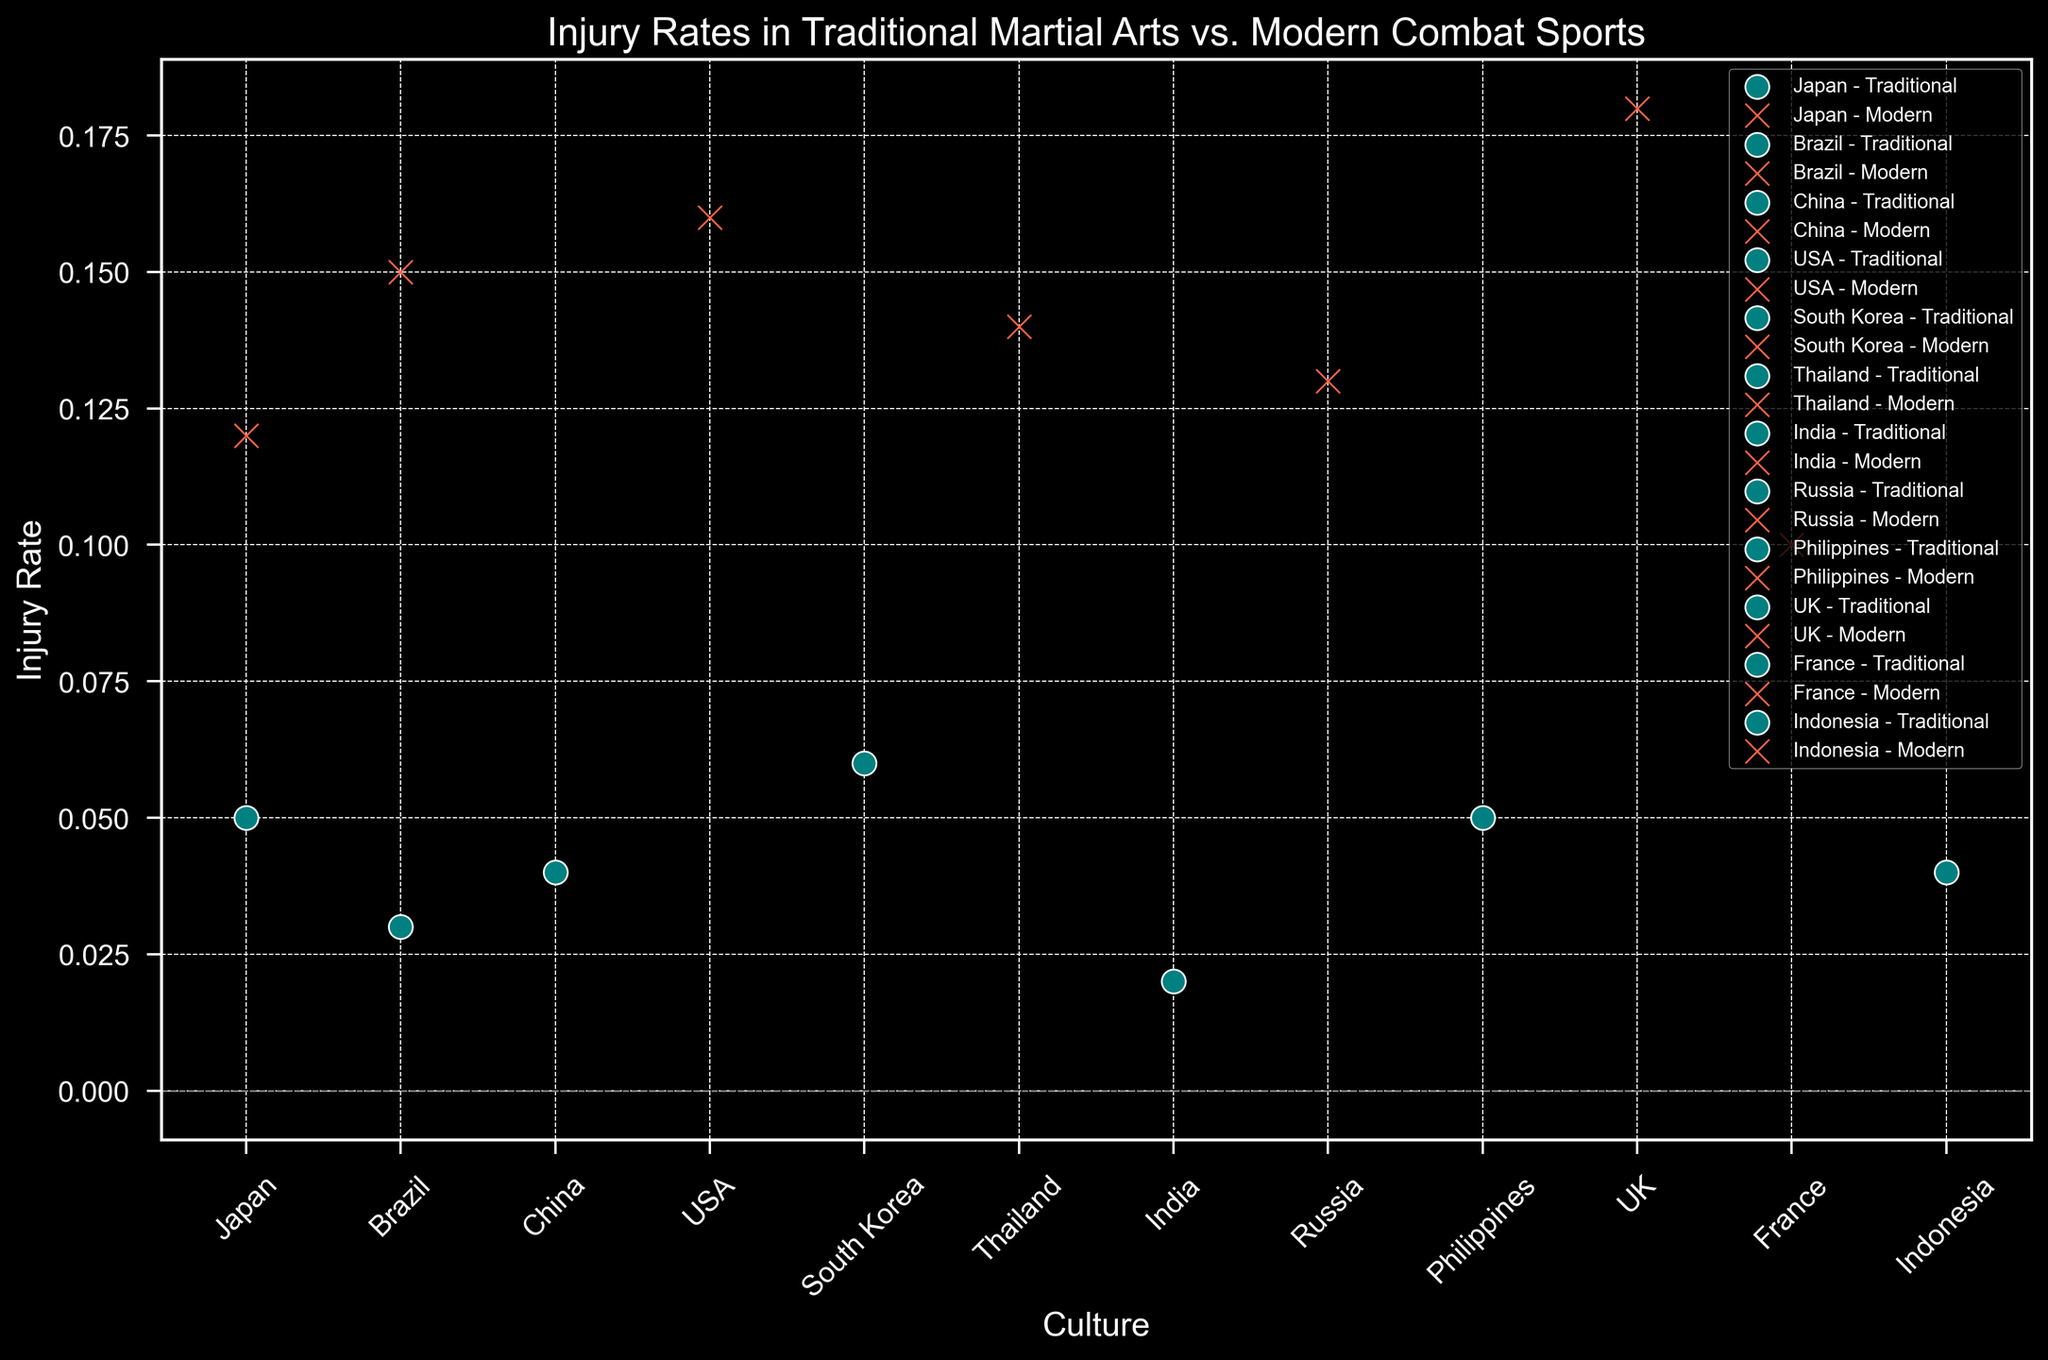How does the injury rate of Karate compare to Kickboxing in Japan? The injury rate of Karate in Japan is 0.05, and for Kickboxing, it is 0.12. By comparing these two rates, it's clear that the injury rate for Kickboxing is higher than for Karate.
Answer: Kickboxing has a higher injury rate What is the average injury rate of traditional martial arts from the given cultures? The traditional martial arts and their injury rates are Karate (0.05), Capoeira (0.03), Kung Fu (0.04), Taekwondo (0.06), Kalaripayattu (0.02), Eskrima (0.05), and Pencak Silat (0.04). The average injury rate is (0.05 + 0.03 + 0.04 + 0.06 + 0.02 + 0.05 + 0.04) / 7 = 0.0414.
Answer: 0.0414 Which culture has the highest injury rate in modern combat sports? By inspecting the injury rates for modern combat sports across different cultures, the UK with Modern Boxing has the highest rate, which is 0.18.
Answer: UK Among the listed countries, which has the lower injury rate, Brazil for Capoeira or Russia for Sambo? The injury rate for Capoeira in Brazil is 0.03, while for Sambo in Russia, it is 0.13. When comparing these two, Brazil has the lower injury rate for Capoeira.
Answer: Brazil What is the combined average injury rate for modern and traditional martial arts in South Korea and Thailand? The injury rates are: South Korea's Taekwondo (Traditional) 0.06 and Thailand's Muay Thai (Modern) 0.14. The average is calculated as (0.06 + 0.14) / 2 = 0.10.
Answer: 0.10 How does the injury rate of Kung Fu in China compare visually with Modern Boxing in the USA? Kung Fu in China has an injury rate of 0.04, indicated by a teal circle in the scatter plot. Modern Boxing in the USA has a rate of 0.16, indicated by a tomato-colored 'x'. Visually, the 'x' mark (Modern Boxing) is higher on the y-axis compared to the circle (Kung Fu), showing a higher injury rate for Modern Boxing.
Answer: Modern Boxing has a higher injury rate Which two modern combat sports have the closest injury rates, and what are those rates? By examining the data, Savate in France (0.10) and Sambo in Russia (0.13) have the closest injury rates among modern combat sports.
Answer: Savate (0.10) and Sambo (0.13) What is the total injury rate for all traditional martial arts combined? Summing up the injury rates for all traditional martial arts: Karate (0.05) + Capoeira (0.03) + Kung Fu (0.04) + Taekwondo (0.06) + Kalaripayattu (0.02) + Eskrima (0.05) + Pencak Silat (0.04) = 0.29.
Answer: 0.29 